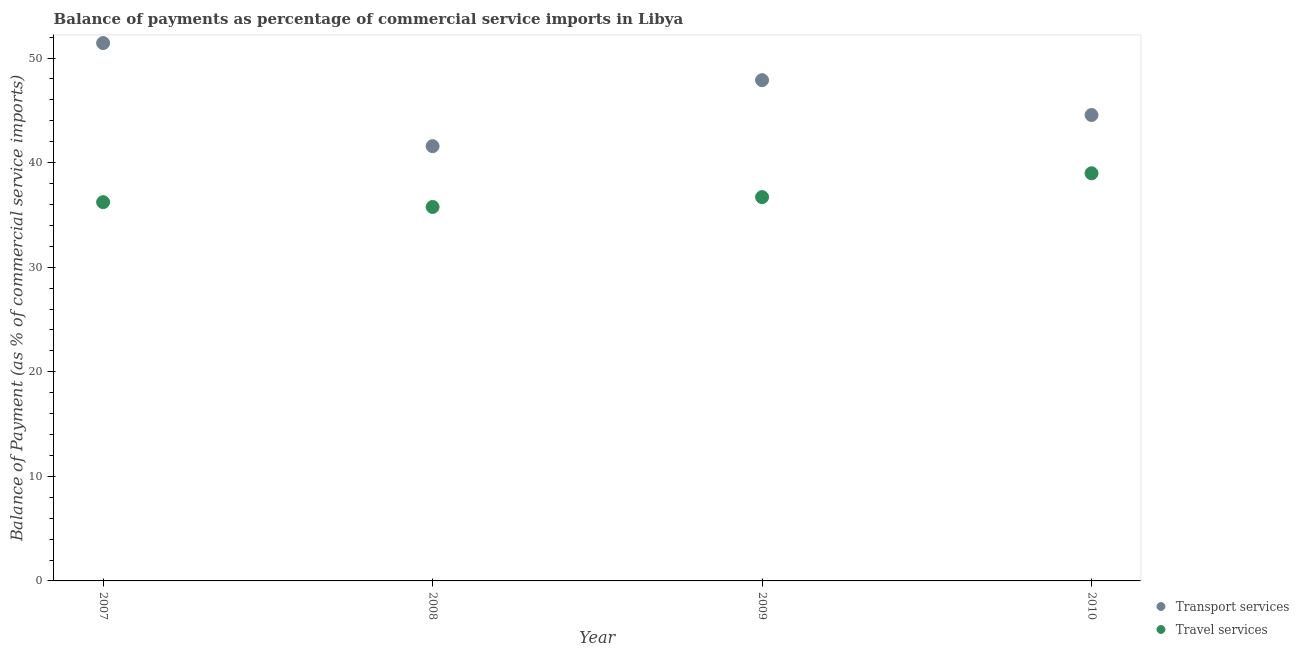How many different coloured dotlines are there?
Provide a short and direct response. 2. What is the balance of payments of transport services in 2007?
Ensure brevity in your answer.  51.44. Across all years, what is the maximum balance of payments of travel services?
Provide a succinct answer. 38.98. Across all years, what is the minimum balance of payments of transport services?
Your response must be concise. 41.58. In which year was the balance of payments of transport services maximum?
Provide a succinct answer. 2007. In which year was the balance of payments of travel services minimum?
Your answer should be compact. 2008. What is the total balance of payments of transport services in the graph?
Make the answer very short. 185.46. What is the difference between the balance of payments of travel services in 2008 and that in 2009?
Your answer should be compact. -0.94. What is the difference between the balance of payments of travel services in 2007 and the balance of payments of transport services in 2009?
Provide a succinct answer. -11.67. What is the average balance of payments of travel services per year?
Your answer should be very brief. 36.92. In the year 2009, what is the difference between the balance of payments of travel services and balance of payments of transport services?
Offer a terse response. -11.18. What is the ratio of the balance of payments of travel services in 2007 to that in 2010?
Make the answer very short. 0.93. What is the difference between the highest and the second highest balance of payments of travel services?
Make the answer very short. 2.28. What is the difference between the highest and the lowest balance of payments of travel services?
Offer a very short reply. 3.22. In how many years, is the balance of payments of transport services greater than the average balance of payments of transport services taken over all years?
Make the answer very short. 2. Is the balance of payments of travel services strictly greater than the balance of payments of transport services over the years?
Give a very brief answer. No. Is the balance of payments of transport services strictly less than the balance of payments of travel services over the years?
Your response must be concise. No. How many dotlines are there?
Your response must be concise. 2. Are the values on the major ticks of Y-axis written in scientific E-notation?
Provide a succinct answer. No. Does the graph contain any zero values?
Ensure brevity in your answer.  No. What is the title of the graph?
Make the answer very short. Balance of payments as percentage of commercial service imports in Libya. Does "Private credit bureau" appear as one of the legend labels in the graph?
Provide a succinct answer. No. What is the label or title of the X-axis?
Your answer should be compact. Year. What is the label or title of the Y-axis?
Make the answer very short. Balance of Payment (as % of commercial service imports). What is the Balance of Payment (as % of commercial service imports) in Transport services in 2007?
Your response must be concise. 51.44. What is the Balance of Payment (as % of commercial service imports) of Travel services in 2007?
Provide a succinct answer. 36.22. What is the Balance of Payment (as % of commercial service imports) of Transport services in 2008?
Keep it short and to the point. 41.58. What is the Balance of Payment (as % of commercial service imports) of Travel services in 2008?
Your response must be concise. 35.76. What is the Balance of Payment (as % of commercial service imports) of Transport services in 2009?
Your answer should be very brief. 47.89. What is the Balance of Payment (as % of commercial service imports) of Travel services in 2009?
Offer a terse response. 36.7. What is the Balance of Payment (as % of commercial service imports) of Transport services in 2010?
Provide a succinct answer. 44.56. What is the Balance of Payment (as % of commercial service imports) in Travel services in 2010?
Your answer should be compact. 38.98. Across all years, what is the maximum Balance of Payment (as % of commercial service imports) of Transport services?
Offer a very short reply. 51.44. Across all years, what is the maximum Balance of Payment (as % of commercial service imports) in Travel services?
Your response must be concise. 38.98. Across all years, what is the minimum Balance of Payment (as % of commercial service imports) of Transport services?
Offer a very short reply. 41.58. Across all years, what is the minimum Balance of Payment (as % of commercial service imports) of Travel services?
Ensure brevity in your answer.  35.76. What is the total Balance of Payment (as % of commercial service imports) in Transport services in the graph?
Your response must be concise. 185.46. What is the total Balance of Payment (as % of commercial service imports) in Travel services in the graph?
Ensure brevity in your answer.  147.67. What is the difference between the Balance of Payment (as % of commercial service imports) of Transport services in 2007 and that in 2008?
Make the answer very short. 9.86. What is the difference between the Balance of Payment (as % of commercial service imports) in Travel services in 2007 and that in 2008?
Provide a short and direct response. 0.46. What is the difference between the Balance of Payment (as % of commercial service imports) in Transport services in 2007 and that in 2009?
Make the answer very short. 3.55. What is the difference between the Balance of Payment (as % of commercial service imports) in Travel services in 2007 and that in 2009?
Keep it short and to the point. -0.48. What is the difference between the Balance of Payment (as % of commercial service imports) of Transport services in 2007 and that in 2010?
Your answer should be compact. 6.88. What is the difference between the Balance of Payment (as % of commercial service imports) in Travel services in 2007 and that in 2010?
Provide a short and direct response. -2.76. What is the difference between the Balance of Payment (as % of commercial service imports) in Transport services in 2008 and that in 2009?
Your answer should be very brief. -6.31. What is the difference between the Balance of Payment (as % of commercial service imports) of Travel services in 2008 and that in 2009?
Provide a short and direct response. -0.94. What is the difference between the Balance of Payment (as % of commercial service imports) of Transport services in 2008 and that in 2010?
Make the answer very short. -2.98. What is the difference between the Balance of Payment (as % of commercial service imports) in Travel services in 2008 and that in 2010?
Offer a terse response. -3.22. What is the difference between the Balance of Payment (as % of commercial service imports) of Transport services in 2009 and that in 2010?
Offer a very short reply. 3.33. What is the difference between the Balance of Payment (as % of commercial service imports) in Travel services in 2009 and that in 2010?
Ensure brevity in your answer.  -2.28. What is the difference between the Balance of Payment (as % of commercial service imports) of Transport services in 2007 and the Balance of Payment (as % of commercial service imports) of Travel services in 2008?
Offer a terse response. 15.67. What is the difference between the Balance of Payment (as % of commercial service imports) in Transport services in 2007 and the Balance of Payment (as % of commercial service imports) in Travel services in 2009?
Make the answer very short. 14.73. What is the difference between the Balance of Payment (as % of commercial service imports) of Transport services in 2007 and the Balance of Payment (as % of commercial service imports) of Travel services in 2010?
Your answer should be very brief. 12.45. What is the difference between the Balance of Payment (as % of commercial service imports) in Transport services in 2008 and the Balance of Payment (as % of commercial service imports) in Travel services in 2009?
Give a very brief answer. 4.87. What is the difference between the Balance of Payment (as % of commercial service imports) in Transport services in 2008 and the Balance of Payment (as % of commercial service imports) in Travel services in 2010?
Make the answer very short. 2.59. What is the difference between the Balance of Payment (as % of commercial service imports) in Transport services in 2009 and the Balance of Payment (as % of commercial service imports) in Travel services in 2010?
Give a very brief answer. 8.9. What is the average Balance of Payment (as % of commercial service imports) of Transport services per year?
Ensure brevity in your answer.  46.36. What is the average Balance of Payment (as % of commercial service imports) in Travel services per year?
Provide a short and direct response. 36.92. In the year 2007, what is the difference between the Balance of Payment (as % of commercial service imports) of Transport services and Balance of Payment (as % of commercial service imports) of Travel services?
Your answer should be compact. 15.21. In the year 2008, what is the difference between the Balance of Payment (as % of commercial service imports) in Transport services and Balance of Payment (as % of commercial service imports) in Travel services?
Offer a terse response. 5.82. In the year 2009, what is the difference between the Balance of Payment (as % of commercial service imports) in Transport services and Balance of Payment (as % of commercial service imports) in Travel services?
Offer a very short reply. 11.18. In the year 2010, what is the difference between the Balance of Payment (as % of commercial service imports) in Transport services and Balance of Payment (as % of commercial service imports) in Travel services?
Your response must be concise. 5.57. What is the ratio of the Balance of Payment (as % of commercial service imports) in Transport services in 2007 to that in 2008?
Your answer should be very brief. 1.24. What is the ratio of the Balance of Payment (as % of commercial service imports) in Travel services in 2007 to that in 2008?
Ensure brevity in your answer.  1.01. What is the ratio of the Balance of Payment (as % of commercial service imports) in Transport services in 2007 to that in 2009?
Your answer should be very brief. 1.07. What is the ratio of the Balance of Payment (as % of commercial service imports) in Travel services in 2007 to that in 2009?
Ensure brevity in your answer.  0.99. What is the ratio of the Balance of Payment (as % of commercial service imports) in Transport services in 2007 to that in 2010?
Provide a short and direct response. 1.15. What is the ratio of the Balance of Payment (as % of commercial service imports) in Travel services in 2007 to that in 2010?
Ensure brevity in your answer.  0.93. What is the ratio of the Balance of Payment (as % of commercial service imports) in Transport services in 2008 to that in 2009?
Provide a short and direct response. 0.87. What is the ratio of the Balance of Payment (as % of commercial service imports) of Travel services in 2008 to that in 2009?
Your answer should be very brief. 0.97. What is the ratio of the Balance of Payment (as % of commercial service imports) in Transport services in 2008 to that in 2010?
Provide a short and direct response. 0.93. What is the ratio of the Balance of Payment (as % of commercial service imports) in Travel services in 2008 to that in 2010?
Provide a succinct answer. 0.92. What is the ratio of the Balance of Payment (as % of commercial service imports) of Transport services in 2009 to that in 2010?
Your answer should be very brief. 1.07. What is the ratio of the Balance of Payment (as % of commercial service imports) of Travel services in 2009 to that in 2010?
Ensure brevity in your answer.  0.94. What is the difference between the highest and the second highest Balance of Payment (as % of commercial service imports) of Transport services?
Your answer should be very brief. 3.55. What is the difference between the highest and the second highest Balance of Payment (as % of commercial service imports) of Travel services?
Provide a succinct answer. 2.28. What is the difference between the highest and the lowest Balance of Payment (as % of commercial service imports) of Transport services?
Your response must be concise. 9.86. What is the difference between the highest and the lowest Balance of Payment (as % of commercial service imports) in Travel services?
Provide a succinct answer. 3.22. 